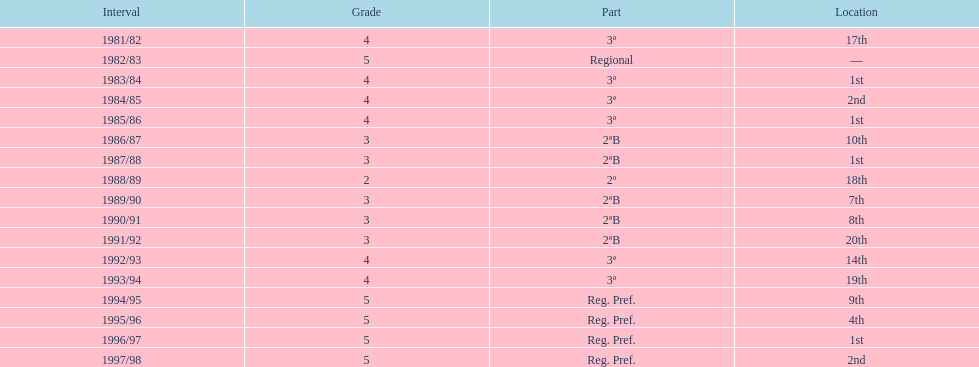Which year has no position pointed out? 1982/83. 